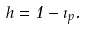Convert formula to latex. <formula><loc_0><loc_0><loc_500><loc_500>h = 1 - \zeta _ { p } .</formula> 